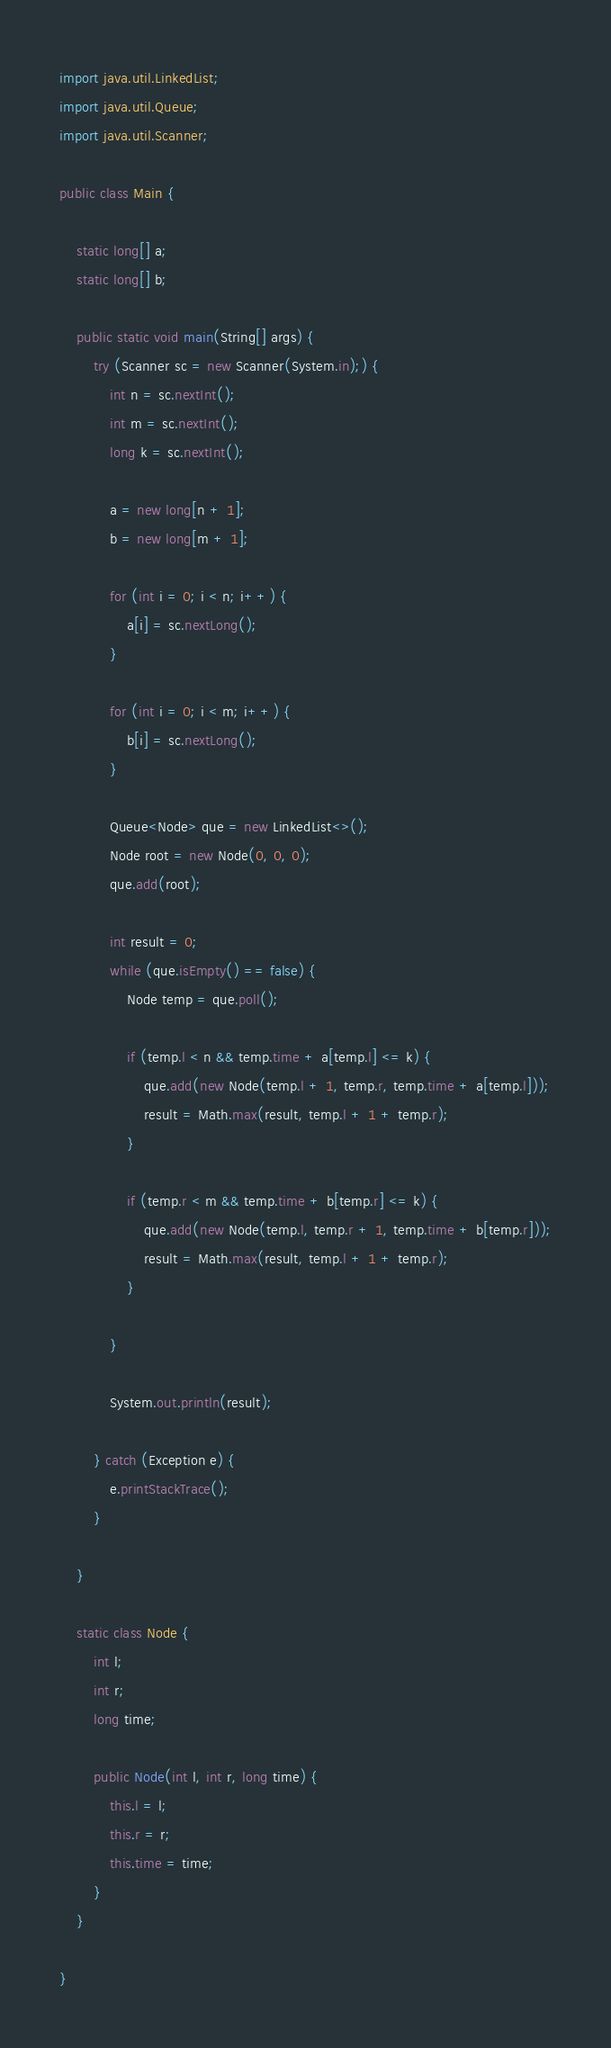<code> <loc_0><loc_0><loc_500><loc_500><_Java_>import java.util.LinkedList;
import java.util.Queue;
import java.util.Scanner;

public class Main {

	static long[] a;
	static long[] b;

	public static void main(String[] args) {
		try (Scanner sc = new Scanner(System.in);) {
			int n = sc.nextInt();
			int m = sc.nextInt();
			long k = sc.nextInt();

			a = new long[n + 1];
			b = new long[m + 1];

			for (int i = 0; i < n; i++) {
				a[i] = sc.nextLong();
			}

			for (int i = 0; i < m; i++) {
				b[i] = sc.nextLong();
			}

			Queue<Node> que = new LinkedList<>();
			Node root = new Node(0, 0, 0);
			que.add(root);

			int result = 0;
			while (que.isEmpty() == false) {
				Node temp = que.poll();

				if (temp.l < n && temp.time + a[temp.l] <= k) {
					que.add(new Node(temp.l + 1, temp.r, temp.time + a[temp.l]));
					result = Math.max(result, temp.l + 1 + temp.r);
				}

				if (temp.r < m && temp.time + b[temp.r] <= k) {
					que.add(new Node(temp.l, temp.r + 1, temp.time + b[temp.r]));
					result = Math.max(result, temp.l + 1 + temp.r);
				}

			}

			System.out.println(result);

		} catch (Exception e) {
			e.printStackTrace();
		}

	}

	static class Node {
		int l;
		int r;
		long time;

		public Node(int l, int r, long time) {
			this.l = l;
			this.r = r;
			this.time = time;
		}
	}

}</code> 